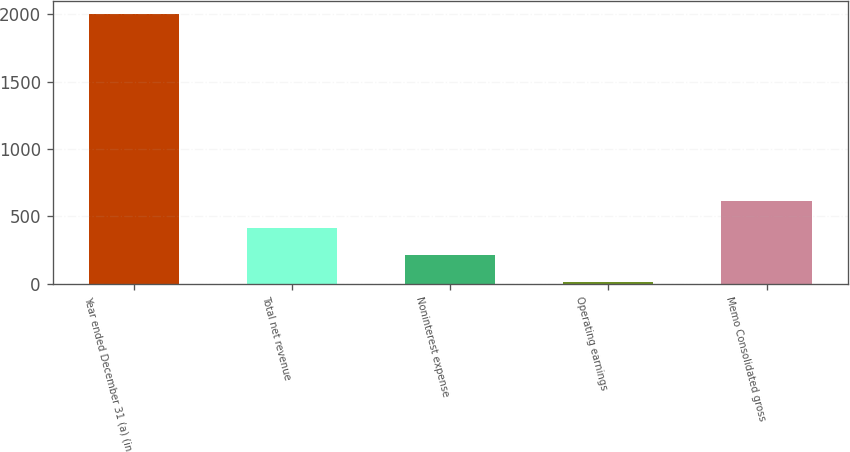Convert chart to OTSL. <chart><loc_0><loc_0><loc_500><loc_500><bar_chart><fcel>Year ended December 31 (a) (in<fcel>Total net revenue<fcel>Noninterest expense<fcel>Operating earnings<fcel>Memo Consolidated gross<nl><fcel>2003<fcel>411<fcel>212<fcel>13<fcel>611<nl></chart> 